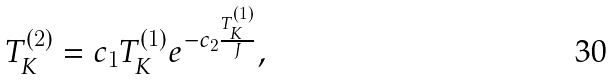Convert formula to latex. <formula><loc_0><loc_0><loc_500><loc_500>T _ { K } ^ { ( 2 ) } = c _ { 1 } T _ { K } ^ { ( 1 ) } e ^ { - c _ { 2 } \frac { T _ { K } ^ { ( 1 ) } } { J } } ,</formula> 